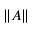<formula> <loc_0><loc_0><loc_500><loc_500>\| A \|</formula> 